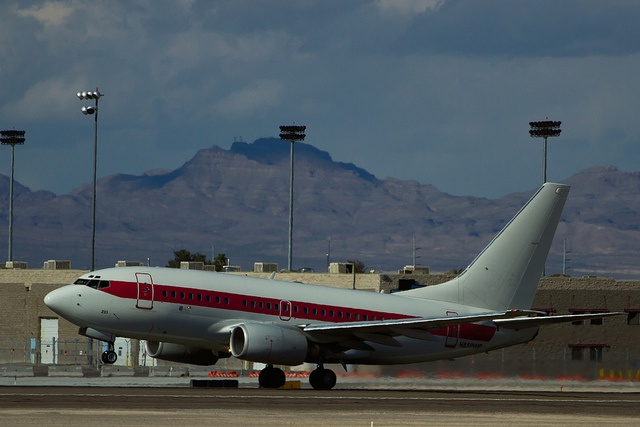Describe the objects in this image and their specific colors. I can see a airplane in blue, black, darkgray, gray, and maroon tones in this image. 